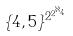Convert formula to latex. <formula><loc_0><loc_0><loc_500><loc_500>\{ 4 , 5 \} ^ { 2 ^ { 2 ^ { \aleph _ { 4 } } } }</formula> 